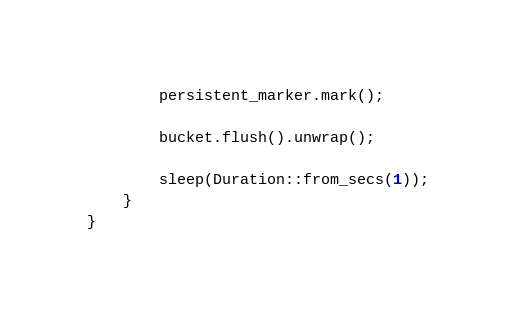<code> <loc_0><loc_0><loc_500><loc_500><_Rust_>        persistent_marker.mark();

        bucket.flush().unwrap();

        sleep(Duration::from_secs(1));
    }
}
</code> 